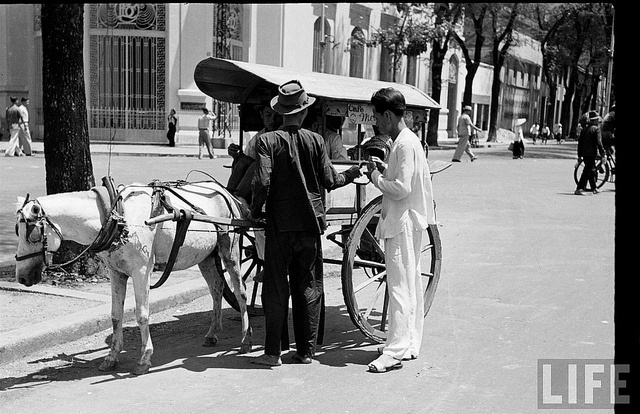Describe the objects in this image and their specific colors. I can see horse in black, lightgray, gray, and darkgray tones, people in black, gray, darkgray, and gainsboro tones, people in black, lightgray, darkgray, and gray tones, people in black, gray, darkgray, and lightgray tones, and people in black, gray, darkgray, and lightgray tones in this image. 